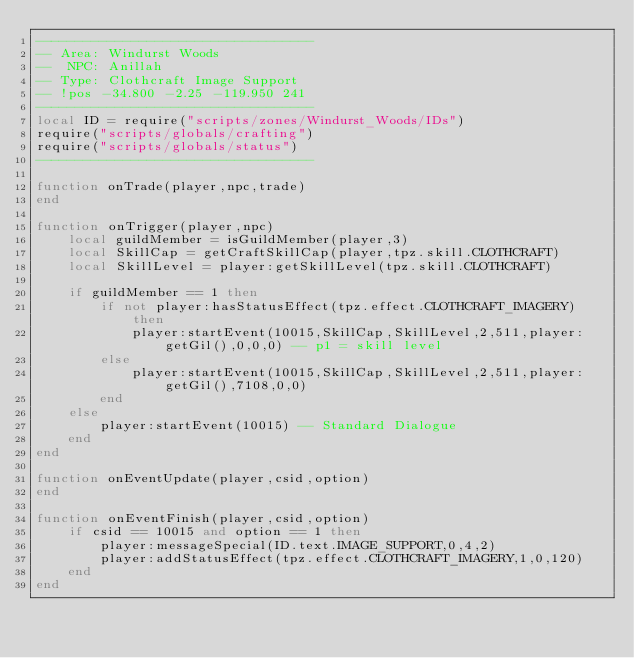Convert code to text. <code><loc_0><loc_0><loc_500><loc_500><_Lua_>-----------------------------------
-- Area: Windurst Woods
--  NPC: Anillah
-- Type: Clothcraft Image Support
-- !pos -34.800 -2.25 -119.950 241
-----------------------------------
local ID = require("scripts/zones/Windurst_Woods/IDs")
require("scripts/globals/crafting")
require("scripts/globals/status")
-----------------------------------

function onTrade(player,npc,trade)
end

function onTrigger(player,npc)
    local guildMember = isGuildMember(player,3)
    local SkillCap = getCraftSkillCap(player,tpz.skill.CLOTHCRAFT)
    local SkillLevel = player:getSkillLevel(tpz.skill.CLOTHCRAFT)

    if guildMember == 1 then
        if not player:hasStatusEffect(tpz.effect.CLOTHCRAFT_IMAGERY) then
            player:startEvent(10015,SkillCap,SkillLevel,2,511,player:getGil(),0,0,0) -- p1 = skill level
        else
            player:startEvent(10015,SkillCap,SkillLevel,2,511,player:getGil(),7108,0,0)
        end
    else
        player:startEvent(10015) -- Standard Dialogue
    end
end

function onEventUpdate(player,csid,option)
end

function onEventFinish(player,csid,option)
    if csid == 10015 and option == 1 then
        player:messageSpecial(ID.text.IMAGE_SUPPORT,0,4,2)
        player:addStatusEffect(tpz.effect.CLOTHCRAFT_IMAGERY,1,0,120)
    end
end
</code> 